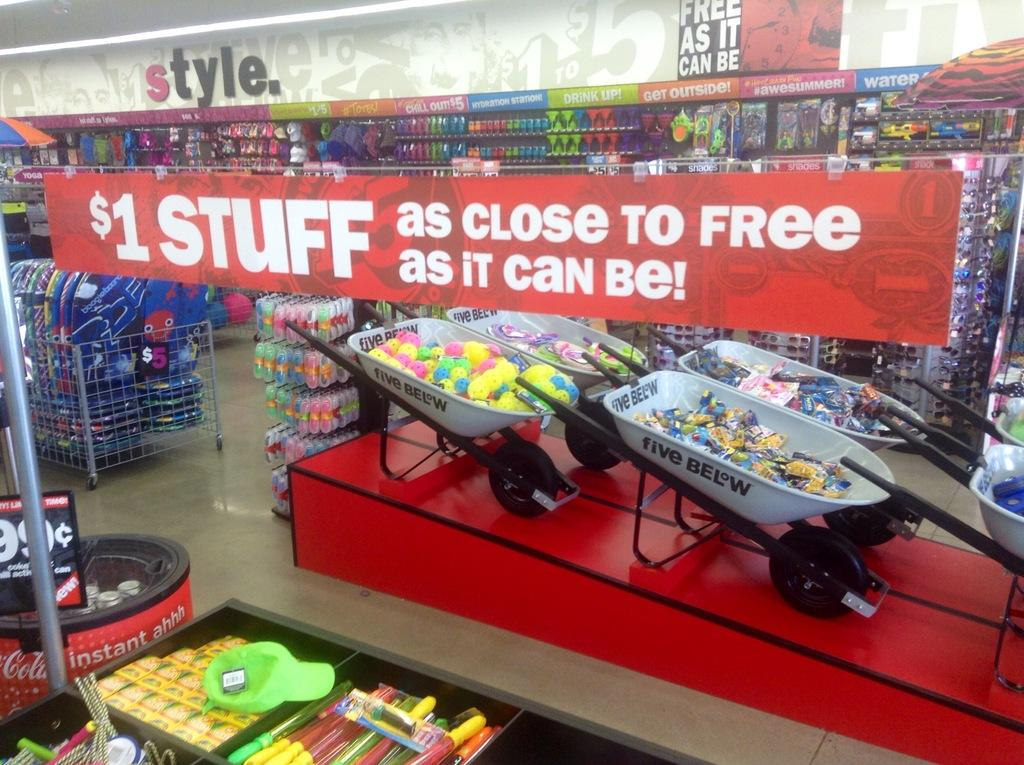<image>
Create a compact narrative representing the image presented. A red banner inside a store advertising stuff for $1. 